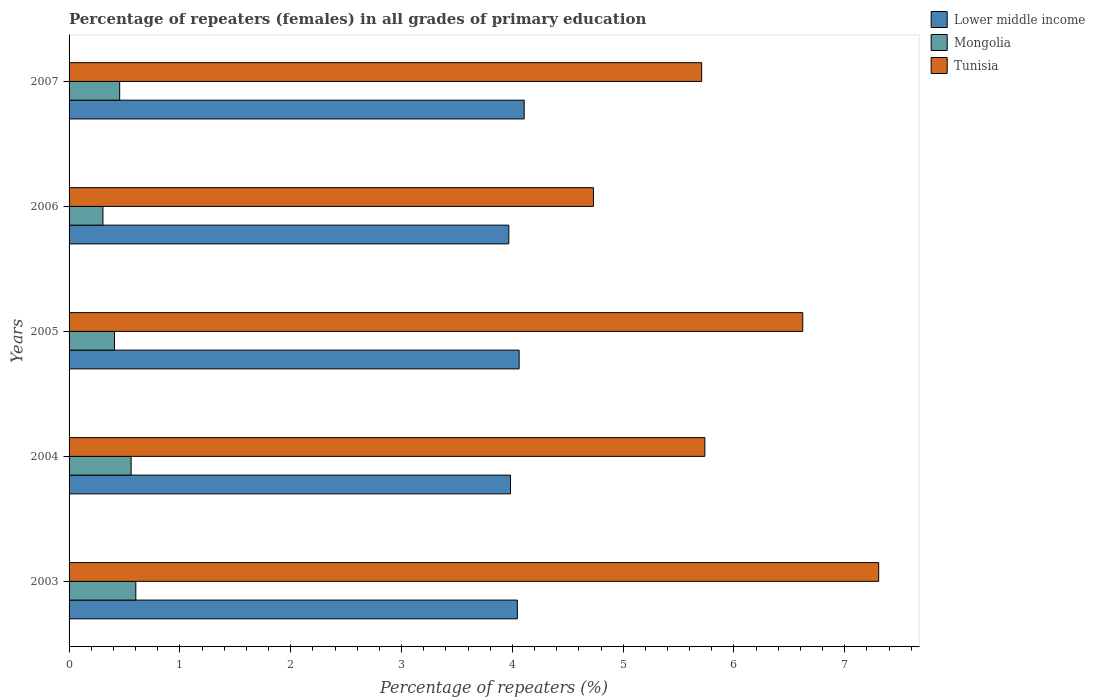Are the number of bars per tick equal to the number of legend labels?
Keep it short and to the point. Yes. Are the number of bars on each tick of the Y-axis equal?
Your response must be concise. Yes. How many bars are there on the 3rd tick from the top?
Ensure brevity in your answer.  3. What is the label of the 1st group of bars from the top?
Keep it short and to the point. 2007. In how many cases, is the number of bars for a given year not equal to the number of legend labels?
Offer a very short reply. 0. What is the percentage of repeaters (females) in Lower middle income in 2005?
Offer a very short reply. 4.06. Across all years, what is the maximum percentage of repeaters (females) in Mongolia?
Provide a succinct answer. 0.6. Across all years, what is the minimum percentage of repeaters (females) in Lower middle income?
Keep it short and to the point. 3.97. What is the total percentage of repeaters (females) in Mongolia in the graph?
Ensure brevity in your answer.  2.34. What is the difference between the percentage of repeaters (females) in Mongolia in 2005 and that in 2007?
Offer a very short reply. -0.05. What is the difference between the percentage of repeaters (females) in Tunisia in 2004 and the percentage of repeaters (females) in Mongolia in 2007?
Your answer should be compact. 5.28. What is the average percentage of repeaters (females) in Mongolia per year?
Ensure brevity in your answer.  0.47. In the year 2003, what is the difference between the percentage of repeaters (females) in Lower middle income and percentage of repeaters (females) in Tunisia?
Give a very brief answer. -3.26. In how many years, is the percentage of repeaters (females) in Tunisia greater than 3 %?
Provide a succinct answer. 5. What is the ratio of the percentage of repeaters (females) in Lower middle income in 2003 to that in 2007?
Offer a terse response. 0.98. What is the difference between the highest and the second highest percentage of repeaters (females) in Tunisia?
Ensure brevity in your answer.  0.69. What is the difference between the highest and the lowest percentage of repeaters (females) in Lower middle income?
Provide a short and direct response. 0.14. In how many years, is the percentage of repeaters (females) in Lower middle income greater than the average percentage of repeaters (females) in Lower middle income taken over all years?
Your answer should be compact. 3. Is the sum of the percentage of repeaters (females) in Tunisia in 2005 and 2006 greater than the maximum percentage of repeaters (females) in Lower middle income across all years?
Make the answer very short. Yes. What does the 3rd bar from the top in 2006 represents?
Ensure brevity in your answer.  Lower middle income. What does the 1st bar from the bottom in 2004 represents?
Provide a succinct answer. Lower middle income. What is the difference between two consecutive major ticks on the X-axis?
Provide a short and direct response. 1. Are the values on the major ticks of X-axis written in scientific E-notation?
Your answer should be compact. No. Does the graph contain any zero values?
Provide a succinct answer. No. Does the graph contain grids?
Keep it short and to the point. No. Where does the legend appear in the graph?
Give a very brief answer. Top right. How are the legend labels stacked?
Your answer should be compact. Vertical. What is the title of the graph?
Give a very brief answer. Percentage of repeaters (females) in all grades of primary education. Does "Tonga" appear as one of the legend labels in the graph?
Your response must be concise. No. What is the label or title of the X-axis?
Give a very brief answer. Percentage of repeaters (%). What is the label or title of the Y-axis?
Offer a terse response. Years. What is the Percentage of repeaters (%) of Lower middle income in 2003?
Provide a succinct answer. 4.05. What is the Percentage of repeaters (%) of Mongolia in 2003?
Ensure brevity in your answer.  0.6. What is the Percentage of repeaters (%) of Tunisia in 2003?
Keep it short and to the point. 7.31. What is the Percentage of repeaters (%) of Lower middle income in 2004?
Offer a terse response. 3.98. What is the Percentage of repeaters (%) in Mongolia in 2004?
Make the answer very short. 0.56. What is the Percentage of repeaters (%) in Tunisia in 2004?
Your answer should be very brief. 5.74. What is the Percentage of repeaters (%) in Lower middle income in 2005?
Ensure brevity in your answer.  4.06. What is the Percentage of repeaters (%) of Mongolia in 2005?
Provide a succinct answer. 0.41. What is the Percentage of repeaters (%) of Tunisia in 2005?
Ensure brevity in your answer.  6.62. What is the Percentage of repeaters (%) of Lower middle income in 2006?
Ensure brevity in your answer.  3.97. What is the Percentage of repeaters (%) in Mongolia in 2006?
Offer a terse response. 0.31. What is the Percentage of repeaters (%) in Tunisia in 2006?
Make the answer very short. 4.73. What is the Percentage of repeaters (%) in Lower middle income in 2007?
Keep it short and to the point. 4.11. What is the Percentage of repeaters (%) in Mongolia in 2007?
Provide a succinct answer. 0.46. What is the Percentage of repeaters (%) of Tunisia in 2007?
Your answer should be compact. 5.71. Across all years, what is the maximum Percentage of repeaters (%) of Lower middle income?
Your response must be concise. 4.11. Across all years, what is the maximum Percentage of repeaters (%) in Mongolia?
Your answer should be very brief. 0.6. Across all years, what is the maximum Percentage of repeaters (%) of Tunisia?
Your answer should be very brief. 7.31. Across all years, what is the minimum Percentage of repeaters (%) of Lower middle income?
Provide a succinct answer. 3.97. Across all years, what is the minimum Percentage of repeaters (%) of Mongolia?
Ensure brevity in your answer.  0.31. Across all years, what is the minimum Percentage of repeaters (%) of Tunisia?
Make the answer very short. 4.73. What is the total Percentage of repeaters (%) of Lower middle income in the graph?
Offer a terse response. 20.16. What is the total Percentage of repeaters (%) of Mongolia in the graph?
Provide a succinct answer. 2.34. What is the total Percentage of repeaters (%) in Tunisia in the graph?
Make the answer very short. 30.1. What is the difference between the Percentage of repeaters (%) of Lower middle income in 2003 and that in 2004?
Provide a short and direct response. 0.06. What is the difference between the Percentage of repeaters (%) in Mongolia in 2003 and that in 2004?
Provide a succinct answer. 0.04. What is the difference between the Percentage of repeaters (%) of Tunisia in 2003 and that in 2004?
Make the answer very short. 1.57. What is the difference between the Percentage of repeaters (%) of Lower middle income in 2003 and that in 2005?
Offer a very short reply. -0.02. What is the difference between the Percentage of repeaters (%) in Mongolia in 2003 and that in 2005?
Offer a terse response. 0.19. What is the difference between the Percentage of repeaters (%) in Tunisia in 2003 and that in 2005?
Offer a very short reply. 0.69. What is the difference between the Percentage of repeaters (%) in Lower middle income in 2003 and that in 2006?
Offer a terse response. 0.08. What is the difference between the Percentage of repeaters (%) of Mongolia in 2003 and that in 2006?
Keep it short and to the point. 0.3. What is the difference between the Percentage of repeaters (%) of Tunisia in 2003 and that in 2006?
Your response must be concise. 2.57. What is the difference between the Percentage of repeaters (%) of Lower middle income in 2003 and that in 2007?
Offer a terse response. -0.06. What is the difference between the Percentage of repeaters (%) of Mongolia in 2003 and that in 2007?
Give a very brief answer. 0.15. What is the difference between the Percentage of repeaters (%) of Tunisia in 2003 and that in 2007?
Your answer should be compact. 1.6. What is the difference between the Percentage of repeaters (%) of Lower middle income in 2004 and that in 2005?
Your answer should be very brief. -0.08. What is the difference between the Percentage of repeaters (%) in Mongolia in 2004 and that in 2005?
Provide a succinct answer. 0.15. What is the difference between the Percentage of repeaters (%) in Tunisia in 2004 and that in 2005?
Your answer should be very brief. -0.88. What is the difference between the Percentage of repeaters (%) in Lower middle income in 2004 and that in 2006?
Offer a terse response. 0.02. What is the difference between the Percentage of repeaters (%) in Mongolia in 2004 and that in 2006?
Keep it short and to the point. 0.25. What is the difference between the Percentage of repeaters (%) of Lower middle income in 2004 and that in 2007?
Offer a very short reply. -0.12. What is the difference between the Percentage of repeaters (%) in Mongolia in 2004 and that in 2007?
Ensure brevity in your answer.  0.1. What is the difference between the Percentage of repeaters (%) in Tunisia in 2004 and that in 2007?
Provide a short and direct response. 0.03. What is the difference between the Percentage of repeaters (%) in Lower middle income in 2005 and that in 2006?
Provide a short and direct response. 0.09. What is the difference between the Percentage of repeaters (%) in Mongolia in 2005 and that in 2006?
Your answer should be very brief. 0.1. What is the difference between the Percentage of repeaters (%) of Tunisia in 2005 and that in 2006?
Make the answer very short. 1.89. What is the difference between the Percentage of repeaters (%) of Lower middle income in 2005 and that in 2007?
Offer a terse response. -0.05. What is the difference between the Percentage of repeaters (%) in Mongolia in 2005 and that in 2007?
Offer a very short reply. -0.05. What is the difference between the Percentage of repeaters (%) of Tunisia in 2005 and that in 2007?
Ensure brevity in your answer.  0.91. What is the difference between the Percentage of repeaters (%) in Lower middle income in 2006 and that in 2007?
Your response must be concise. -0.14. What is the difference between the Percentage of repeaters (%) in Mongolia in 2006 and that in 2007?
Keep it short and to the point. -0.15. What is the difference between the Percentage of repeaters (%) of Tunisia in 2006 and that in 2007?
Ensure brevity in your answer.  -0.98. What is the difference between the Percentage of repeaters (%) in Lower middle income in 2003 and the Percentage of repeaters (%) in Mongolia in 2004?
Give a very brief answer. 3.48. What is the difference between the Percentage of repeaters (%) in Lower middle income in 2003 and the Percentage of repeaters (%) in Tunisia in 2004?
Offer a very short reply. -1.69. What is the difference between the Percentage of repeaters (%) in Mongolia in 2003 and the Percentage of repeaters (%) in Tunisia in 2004?
Ensure brevity in your answer.  -5.13. What is the difference between the Percentage of repeaters (%) in Lower middle income in 2003 and the Percentage of repeaters (%) in Mongolia in 2005?
Make the answer very short. 3.64. What is the difference between the Percentage of repeaters (%) of Lower middle income in 2003 and the Percentage of repeaters (%) of Tunisia in 2005?
Your response must be concise. -2.58. What is the difference between the Percentage of repeaters (%) in Mongolia in 2003 and the Percentage of repeaters (%) in Tunisia in 2005?
Offer a very short reply. -6.02. What is the difference between the Percentage of repeaters (%) in Lower middle income in 2003 and the Percentage of repeaters (%) in Mongolia in 2006?
Your answer should be compact. 3.74. What is the difference between the Percentage of repeaters (%) of Lower middle income in 2003 and the Percentage of repeaters (%) of Tunisia in 2006?
Your answer should be very brief. -0.69. What is the difference between the Percentage of repeaters (%) in Mongolia in 2003 and the Percentage of repeaters (%) in Tunisia in 2006?
Keep it short and to the point. -4.13. What is the difference between the Percentage of repeaters (%) of Lower middle income in 2003 and the Percentage of repeaters (%) of Mongolia in 2007?
Provide a short and direct response. 3.59. What is the difference between the Percentage of repeaters (%) in Lower middle income in 2003 and the Percentage of repeaters (%) in Tunisia in 2007?
Your answer should be compact. -1.66. What is the difference between the Percentage of repeaters (%) in Mongolia in 2003 and the Percentage of repeaters (%) in Tunisia in 2007?
Keep it short and to the point. -5.11. What is the difference between the Percentage of repeaters (%) in Lower middle income in 2004 and the Percentage of repeaters (%) in Mongolia in 2005?
Your answer should be very brief. 3.57. What is the difference between the Percentage of repeaters (%) in Lower middle income in 2004 and the Percentage of repeaters (%) in Tunisia in 2005?
Offer a very short reply. -2.64. What is the difference between the Percentage of repeaters (%) of Mongolia in 2004 and the Percentage of repeaters (%) of Tunisia in 2005?
Offer a terse response. -6.06. What is the difference between the Percentage of repeaters (%) in Lower middle income in 2004 and the Percentage of repeaters (%) in Mongolia in 2006?
Your answer should be compact. 3.68. What is the difference between the Percentage of repeaters (%) of Lower middle income in 2004 and the Percentage of repeaters (%) of Tunisia in 2006?
Keep it short and to the point. -0.75. What is the difference between the Percentage of repeaters (%) in Mongolia in 2004 and the Percentage of repeaters (%) in Tunisia in 2006?
Keep it short and to the point. -4.17. What is the difference between the Percentage of repeaters (%) in Lower middle income in 2004 and the Percentage of repeaters (%) in Mongolia in 2007?
Ensure brevity in your answer.  3.53. What is the difference between the Percentage of repeaters (%) in Lower middle income in 2004 and the Percentage of repeaters (%) in Tunisia in 2007?
Offer a very short reply. -1.73. What is the difference between the Percentage of repeaters (%) in Mongolia in 2004 and the Percentage of repeaters (%) in Tunisia in 2007?
Give a very brief answer. -5.15. What is the difference between the Percentage of repeaters (%) in Lower middle income in 2005 and the Percentage of repeaters (%) in Mongolia in 2006?
Your answer should be very brief. 3.76. What is the difference between the Percentage of repeaters (%) of Lower middle income in 2005 and the Percentage of repeaters (%) of Tunisia in 2006?
Give a very brief answer. -0.67. What is the difference between the Percentage of repeaters (%) in Mongolia in 2005 and the Percentage of repeaters (%) in Tunisia in 2006?
Offer a terse response. -4.32. What is the difference between the Percentage of repeaters (%) in Lower middle income in 2005 and the Percentage of repeaters (%) in Mongolia in 2007?
Offer a terse response. 3.6. What is the difference between the Percentage of repeaters (%) of Lower middle income in 2005 and the Percentage of repeaters (%) of Tunisia in 2007?
Your response must be concise. -1.65. What is the difference between the Percentage of repeaters (%) in Mongolia in 2005 and the Percentage of repeaters (%) in Tunisia in 2007?
Provide a succinct answer. -5.3. What is the difference between the Percentage of repeaters (%) of Lower middle income in 2006 and the Percentage of repeaters (%) of Mongolia in 2007?
Your answer should be compact. 3.51. What is the difference between the Percentage of repeaters (%) of Lower middle income in 2006 and the Percentage of repeaters (%) of Tunisia in 2007?
Your response must be concise. -1.74. What is the difference between the Percentage of repeaters (%) of Mongolia in 2006 and the Percentage of repeaters (%) of Tunisia in 2007?
Offer a very short reply. -5.4. What is the average Percentage of repeaters (%) in Lower middle income per year?
Give a very brief answer. 4.03. What is the average Percentage of repeaters (%) of Mongolia per year?
Your response must be concise. 0.47. What is the average Percentage of repeaters (%) in Tunisia per year?
Your answer should be very brief. 6.02. In the year 2003, what is the difference between the Percentage of repeaters (%) in Lower middle income and Percentage of repeaters (%) in Mongolia?
Offer a very short reply. 3.44. In the year 2003, what is the difference between the Percentage of repeaters (%) of Lower middle income and Percentage of repeaters (%) of Tunisia?
Make the answer very short. -3.26. In the year 2003, what is the difference between the Percentage of repeaters (%) in Mongolia and Percentage of repeaters (%) in Tunisia?
Provide a short and direct response. -6.7. In the year 2004, what is the difference between the Percentage of repeaters (%) in Lower middle income and Percentage of repeaters (%) in Mongolia?
Provide a succinct answer. 3.42. In the year 2004, what is the difference between the Percentage of repeaters (%) of Lower middle income and Percentage of repeaters (%) of Tunisia?
Your answer should be very brief. -1.75. In the year 2004, what is the difference between the Percentage of repeaters (%) in Mongolia and Percentage of repeaters (%) in Tunisia?
Your response must be concise. -5.18. In the year 2005, what is the difference between the Percentage of repeaters (%) in Lower middle income and Percentage of repeaters (%) in Mongolia?
Keep it short and to the point. 3.65. In the year 2005, what is the difference between the Percentage of repeaters (%) in Lower middle income and Percentage of repeaters (%) in Tunisia?
Provide a succinct answer. -2.56. In the year 2005, what is the difference between the Percentage of repeaters (%) of Mongolia and Percentage of repeaters (%) of Tunisia?
Provide a short and direct response. -6.21. In the year 2006, what is the difference between the Percentage of repeaters (%) of Lower middle income and Percentage of repeaters (%) of Mongolia?
Offer a very short reply. 3.66. In the year 2006, what is the difference between the Percentage of repeaters (%) of Lower middle income and Percentage of repeaters (%) of Tunisia?
Ensure brevity in your answer.  -0.76. In the year 2006, what is the difference between the Percentage of repeaters (%) in Mongolia and Percentage of repeaters (%) in Tunisia?
Offer a very short reply. -4.43. In the year 2007, what is the difference between the Percentage of repeaters (%) of Lower middle income and Percentage of repeaters (%) of Mongolia?
Ensure brevity in your answer.  3.65. In the year 2007, what is the difference between the Percentage of repeaters (%) in Lower middle income and Percentage of repeaters (%) in Tunisia?
Make the answer very short. -1.6. In the year 2007, what is the difference between the Percentage of repeaters (%) of Mongolia and Percentage of repeaters (%) of Tunisia?
Provide a succinct answer. -5.25. What is the ratio of the Percentage of repeaters (%) in Lower middle income in 2003 to that in 2004?
Make the answer very short. 1.02. What is the ratio of the Percentage of repeaters (%) of Mongolia in 2003 to that in 2004?
Make the answer very short. 1.07. What is the ratio of the Percentage of repeaters (%) in Tunisia in 2003 to that in 2004?
Make the answer very short. 1.27. What is the ratio of the Percentage of repeaters (%) in Lower middle income in 2003 to that in 2005?
Your answer should be compact. 1. What is the ratio of the Percentage of repeaters (%) in Mongolia in 2003 to that in 2005?
Offer a terse response. 1.47. What is the ratio of the Percentage of repeaters (%) of Tunisia in 2003 to that in 2005?
Give a very brief answer. 1.1. What is the ratio of the Percentage of repeaters (%) of Lower middle income in 2003 to that in 2006?
Offer a terse response. 1.02. What is the ratio of the Percentage of repeaters (%) in Mongolia in 2003 to that in 2006?
Provide a succinct answer. 1.97. What is the ratio of the Percentage of repeaters (%) in Tunisia in 2003 to that in 2006?
Your answer should be compact. 1.54. What is the ratio of the Percentage of repeaters (%) of Lower middle income in 2003 to that in 2007?
Give a very brief answer. 0.98. What is the ratio of the Percentage of repeaters (%) of Mongolia in 2003 to that in 2007?
Offer a terse response. 1.32. What is the ratio of the Percentage of repeaters (%) of Tunisia in 2003 to that in 2007?
Ensure brevity in your answer.  1.28. What is the ratio of the Percentage of repeaters (%) in Lower middle income in 2004 to that in 2005?
Ensure brevity in your answer.  0.98. What is the ratio of the Percentage of repeaters (%) of Mongolia in 2004 to that in 2005?
Provide a short and direct response. 1.37. What is the ratio of the Percentage of repeaters (%) of Tunisia in 2004 to that in 2005?
Your answer should be very brief. 0.87. What is the ratio of the Percentage of repeaters (%) in Mongolia in 2004 to that in 2006?
Offer a terse response. 1.83. What is the ratio of the Percentage of repeaters (%) of Tunisia in 2004 to that in 2006?
Offer a terse response. 1.21. What is the ratio of the Percentage of repeaters (%) of Lower middle income in 2004 to that in 2007?
Provide a succinct answer. 0.97. What is the ratio of the Percentage of repeaters (%) of Mongolia in 2004 to that in 2007?
Keep it short and to the point. 1.23. What is the ratio of the Percentage of repeaters (%) in Lower middle income in 2005 to that in 2006?
Ensure brevity in your answer.  1.02. What is the ratio of the Percentage of repeaters (%) of Mongolia in 2005 to that in 2006?
Provide a succinct answer. 1.34. What is the ratio of the Percentage of repeaters (%) of Tunisia in 2005 to that in 2006?
Ensure brevity in your answer.  1.4. What is the ratio of the Percentage of repeaters (%) of Lower middle income in 2005 to that in 2007?
Offer a terse response. 0.99. What is the ratio of the Percentage of repeaters (%) in Mongolia in 2005 to that in 2007?
Your answer should be very brief. 0.9. What is the ratio of the Percentage of repeaters (%) of Tunisia in 2005 to that in 2007?
Your response must be concise. 1.16. What is the ratio of the Percentage of repeaters (%) in Lower middle income in 2006 to that in 2007?
Ensure brevity in your answer.  0.97. What is the ratio of the Percentage of repeaters (%) in Mongolia in 2006 to that in 2007?
Offer a very short reply. 0.67. What is the ratio of the Percentage of repeaters (%) of Tunisia in 2006 to that in 2007?
Your answer should be compact. 0.83. What is the difference between the highest and the second highest Percentage of repeaters (%) of Lower middle income?
Keep it short and to the point. 0.05. What is the difference between the highest and the second highest Percentage of repeaters (%) in Mongolia?
Offer a terse response. 0.04. What is the difference between the highest and the second highest Percentage of repeaters (%) of Tunisia?
Your response must be concise. 0.69. What is the difference between the highest and the lowest Percentage of repeaters (%) in Lower middle income?
Provide a succinct answer. 0.14. What is the difference between the highest and the lowest Percentage of repeaters (%) in Mongolia?
Your answer should be compact. 0.3. What is the difference between the highest and the lowest Percentage of repeaters (%) of Tunisia?
Give a very brief answer. 2.57. 